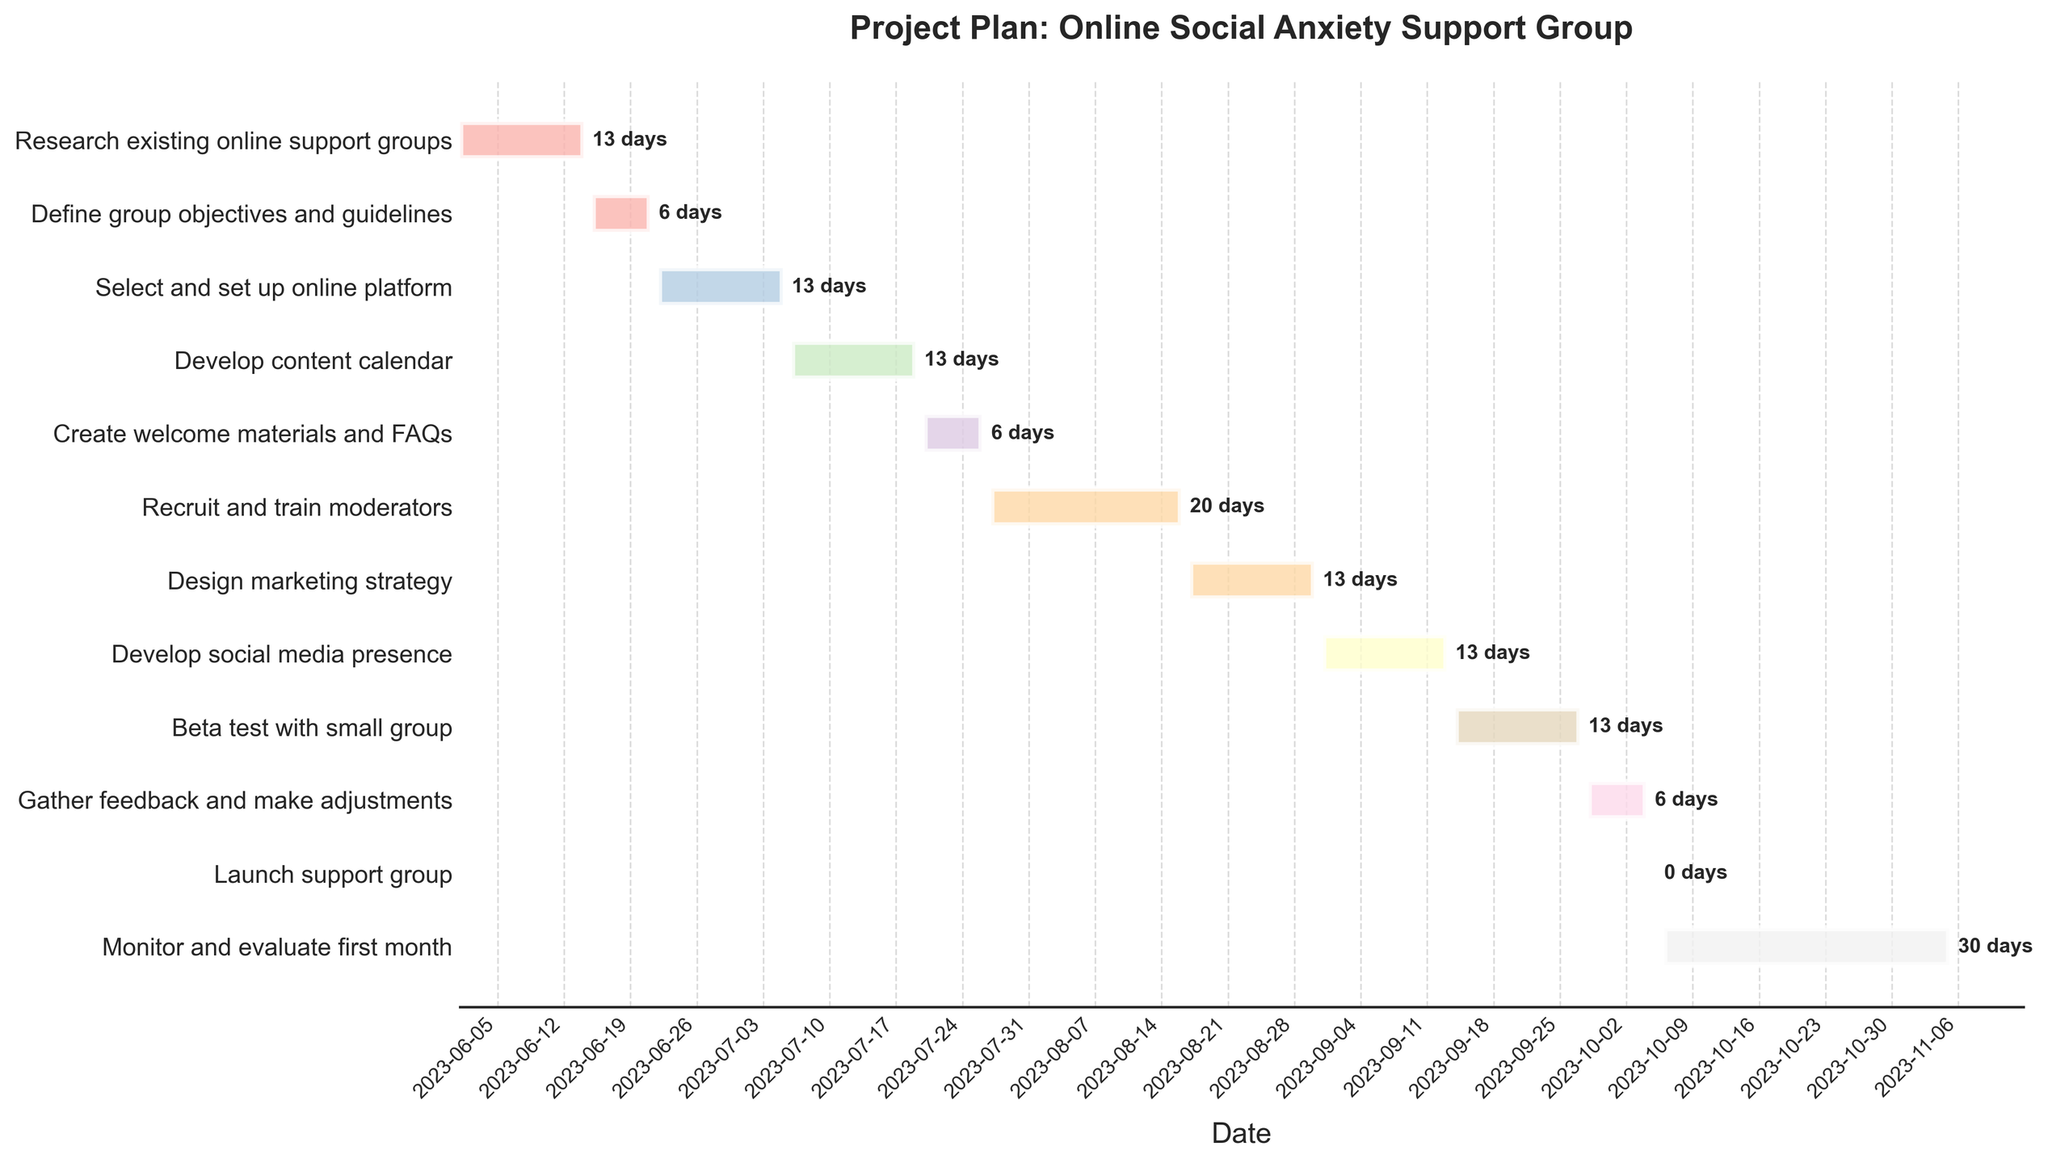Which task has the shortest duration? To identify the task with the shortest duration, review the duration annotations for each task on the Gantt Chart. The shortest duration on the chart is 1 day, corresponding to the "Launch support group" task.
Answer: Launch support group What's the last task in the project? The last task is the final one on the y-axis and timeline. In this chart, the "Monitor and evaluate first month" task appears at the end and spans until 2023-11-05.
Answer: Monitor and evaluate first month How many tasks have a duration of exactly 14 days? Count the tasks annotated with 14 days' duration on the Gantt Chart. Tasks listed are "Research existing online support groups," "Select and set up online platform," "Develop content calendar," "Design marketing strategy," "Develop social media presence," and "Beta test with small group," summing to six tasks.
Answer: 6 Which tasks span the entire month of July? To find tasks spanning July, look at bars covering dates from 2023-07-01 to 2023-07-31. The relevant tasks are "Develop content calendar," "Create welcome materials and FAQs," and "Recruit and train moderators."
Answer: Develop content calendar, Create welcome materials and FAQs, Recruit and train moderators What is the combined duration for "Develop social media presence" and "Beta test with small group"? Summing durations of "Develop social media presence" (14 days) and "Beta test with small group" (14 days) results in 14 + 14 = 28 days.
Answer: 28 days Which task ends first after the "Define group objectives and guidelines"? Identify the task immediately following "Define group objectives and guidelines." The next task, "Select and set up online platform," ends on 2023-07-05, the earliest end date among subsequent tasks.
Answer: Select and set up online platform What is the primary color used for the "Create welcome materials and FAQs" task? Observe the color assigned to the "Create welcome materials and FAQs" bar. It appears as a specific pastel color based on the given palette.
Answer: Pastel color (specific shade not named in the description) How long does the "Monitor and evaluate first month" task last? Check the annotation for the "Monitor and evaluate first month" task duration, which is 31 days.
Answer: 31 days Which tasks involve preparation for launching the support group itself? Analyze tasks leading up to "Launch support group." These preparatory tasks are "Create welcome materials and FAQs," "Recruit and train moderators," "Design marketing strategy," "Develop social media presence," "Beta test with small group," and "Gather feedback and make adjustments."
Answer: Create welcome materials and FAQs, Recruit and train moderators, Design marketing strategy, Develop social media presence, Beta test with small group, Gather feedback and make adjustments 